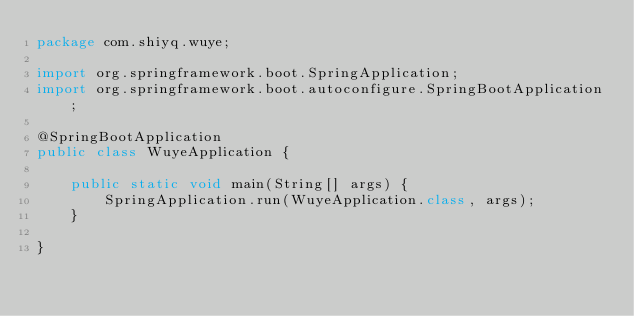Convert code to text. <code><loc_0><loc_0><loc_500><loc_500><_Java_>package com.shiyq.wuye;

import org.springframework.boot.SpringApplication;
import org.springframework.boot.autoconfigure.SpringBootApplication;

@SpringBootApplication
public class WuyeApplication {

    public static void main(String[] args) {
        SpringApplication.run(WuyeApplication.class, args);
    }

}
</code> 